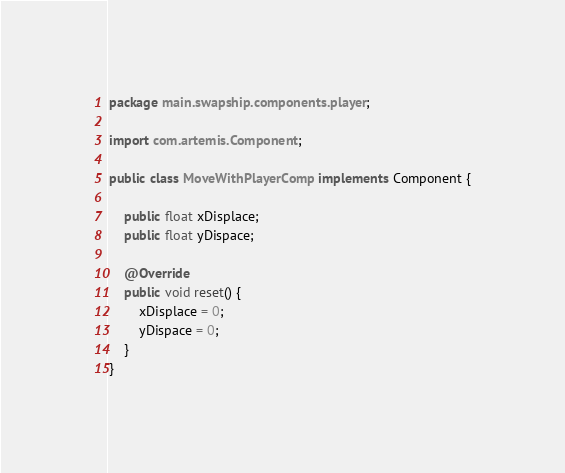Convert code to text. <code><loc_0><loc_0><loc_500><loc_500><_Java_>package main.swapship.components.player;

import com.artemis.Component;

public class MoveWithPlayerComp implements Component {

	public float xDisplace;
	public float yDispace;
	
	@Override
	public void reset() {
		xDisplace = 0;
		yDispace = 0;
	}
}
</code> 